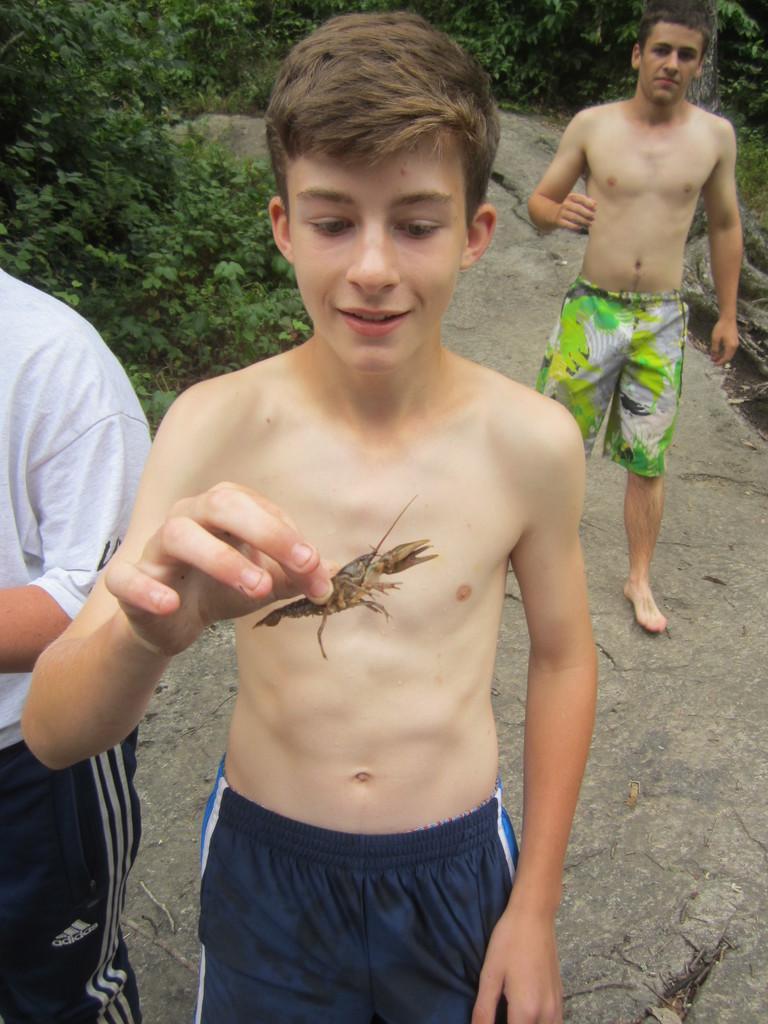How would you summarize this image in a sentence or two? In the picture there are three men present, one person is catching an insect present, there are trees. 